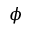<formula> <loc_0><loc_0><loc_500><loc_500>\phi</formula> 